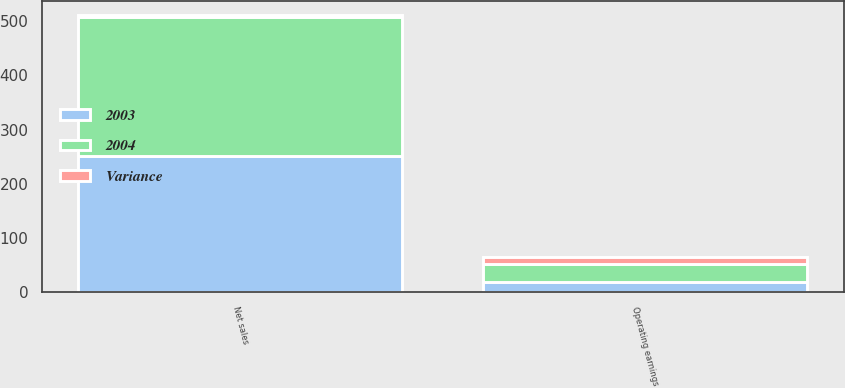<chart> <loc_0><loc_0><loc_500><loc_500><stacked_bar_chart><ecel><fcel>Net sales<fcel>Operating earnings<nl><fcel>2003<fcel>252<fcel>19<nl><fcel>2004<fcel>256<fcel>32<nl><fcel>Variance<fcel>4<fcel>13<nl></chart> 